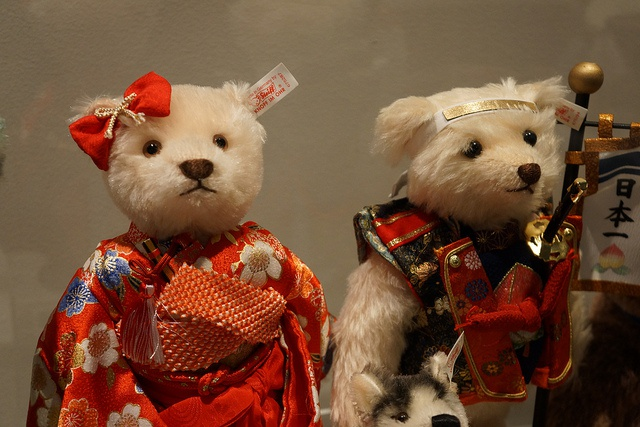Describe the objects in this image and their specific colors. I can see teddy bear in gray, maroon, black, and tan tones and teddy bear in gray, black, maroon, and tan tones in this image. 